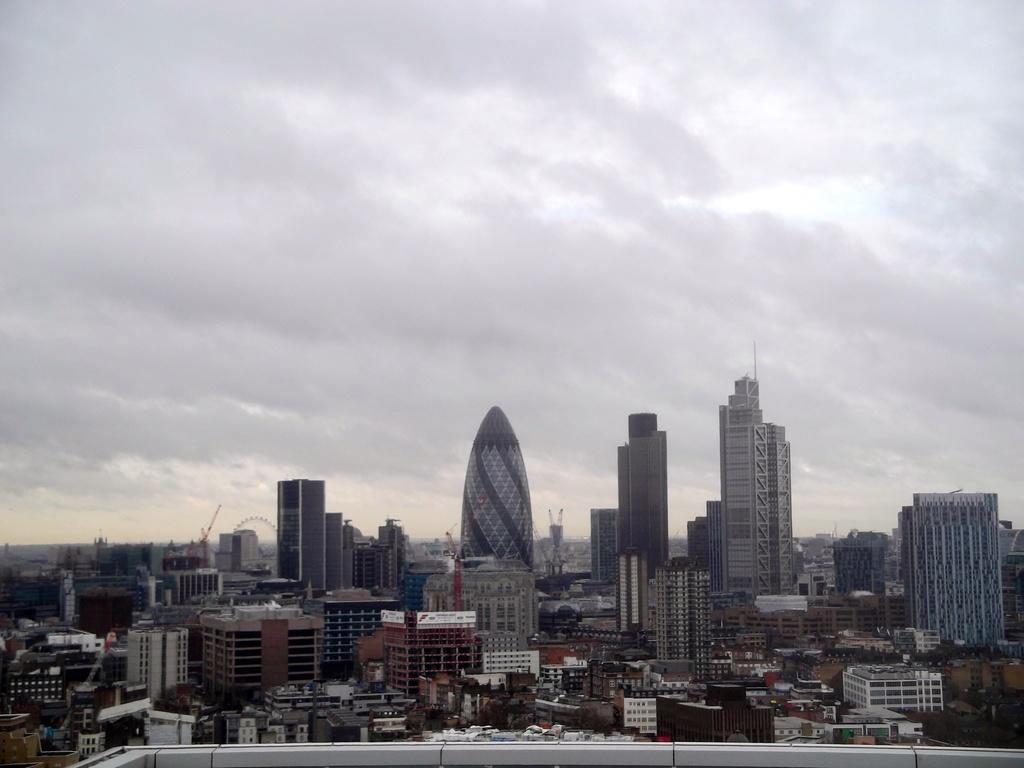What type of view is provided in the image? The image is an aerial view. What structures can be seen from this perspective? There are buildings visible in the image. What type of natural elements are present in the image? Trees are present in the image. What else can be seen in the sky besides the buildings and trees? The sky is visible in the image, and clouds are observable. What type of silk is being used to create the buildings in the image? There is no silk present in the image, and the buildings are not made of silk. 